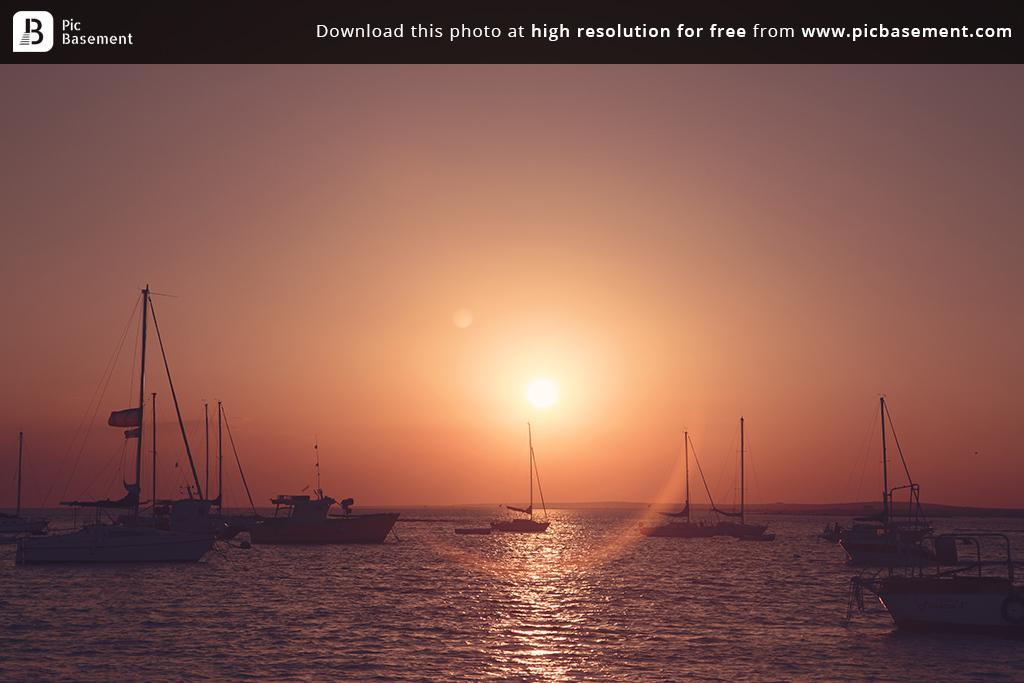What type of vehicles are in the image? There are boats in the image. What is the boats are floating on? There is water visible in the image. What can be seen in the background of the image? The sun is visible in the background of the image. What type of quiver can be seen in the image? There is no quiver present in the image. What station is visible in the image? There is no station visible in the image. 